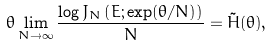<formula> <loc_0><loc_0><loc_500><loc_500>\theta \lim _ { N \to \infty } \frac { \log { J _ { N } \left ( E ; \exp ( \theta / N ) \right ) } } { N } = \tilde { H } ( \theta ) ,</formula> 